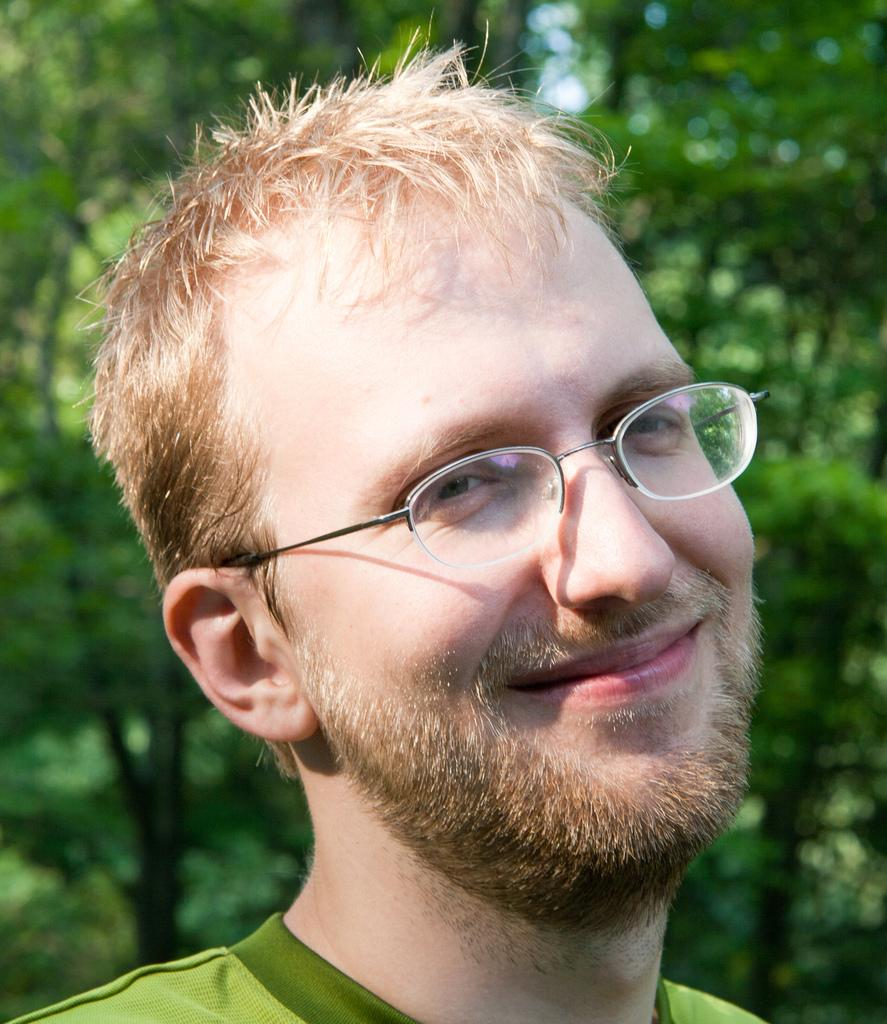Who is present in the image? There is a man in the image. What expression does the man have? The man is smiling. What can be seen in the background of the image? There are green trees in the background of the image. How many snails are crawling on the man's shoulder in the image? There are no snails present in the image; only the man and the green trees in the background can be seen. 